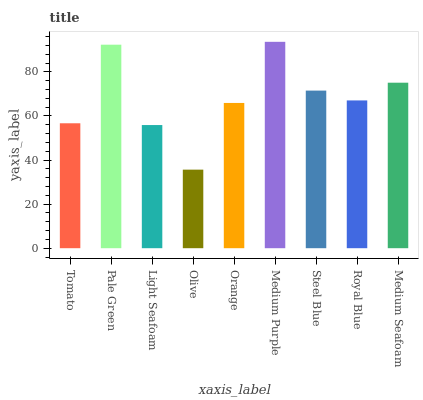Is Olive the minimum?
Answer yes or no. Yes. Is Medium Purple the maximum?
Answer yes or no. Yes. Is Pale Green the minimum?
Answer yes or no. No. Is Pale Green the maximum?
Answer yes or no. No. Is Pale Green greater than Tomato?
Answer yes or no. Yes. Is Tomato less than Pale Green?
Answer yes or no. Yes. Is Tomato greater than Pale Green?
Answer yes or no. No. Is Pale Green less than Tomato?
Answer yes or no. No. Is Royal Blue the high median?
Answer yes or no. Yes. Is Royal Blue the low median?
Answer yes or no. Yes. Is Orange the high median?
Answer yes or no. No. Is Pale Green the low median?
Answer yes or no. No. 